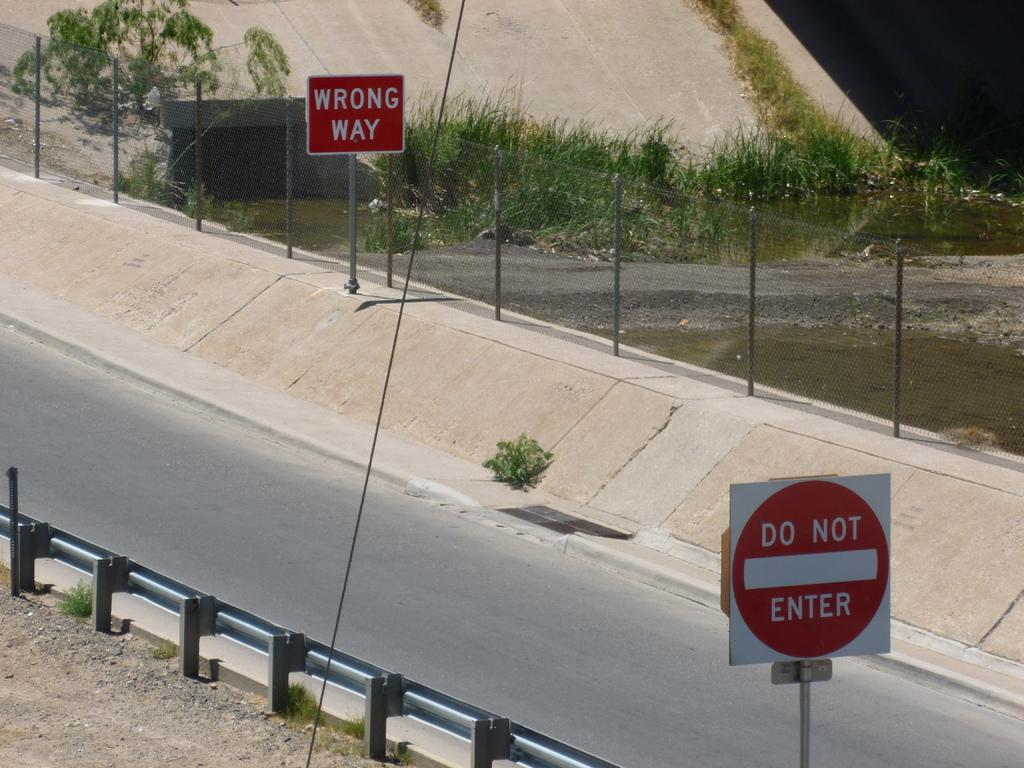<image>
Provide a brief description of the given image. a do not enter sign is above the street 